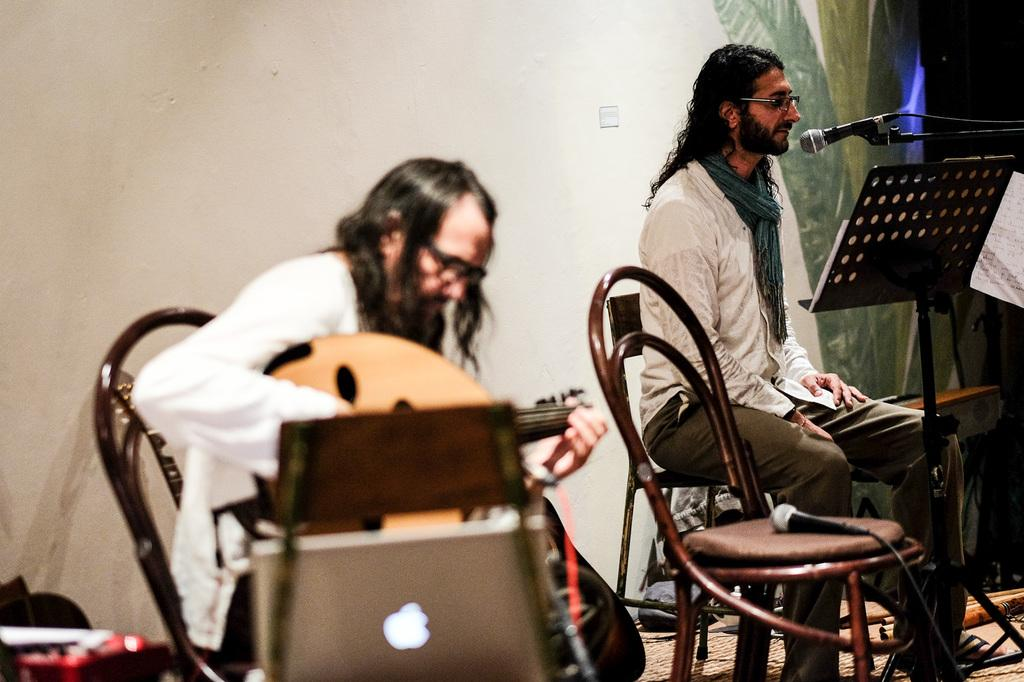How many people are in the image? There are two men in the image. What are the men doing in the image? The first person is playing a guitar, and the second person is singing a song. Are the men interacting with each other in the image? Yes, they are sitting beside each other. What can be seen in the background of the image? There is a wall in the background of the image. What type of toys are the men playing with in the image? There are no toys present in the image; the men are playing a guitar and singing a song. 